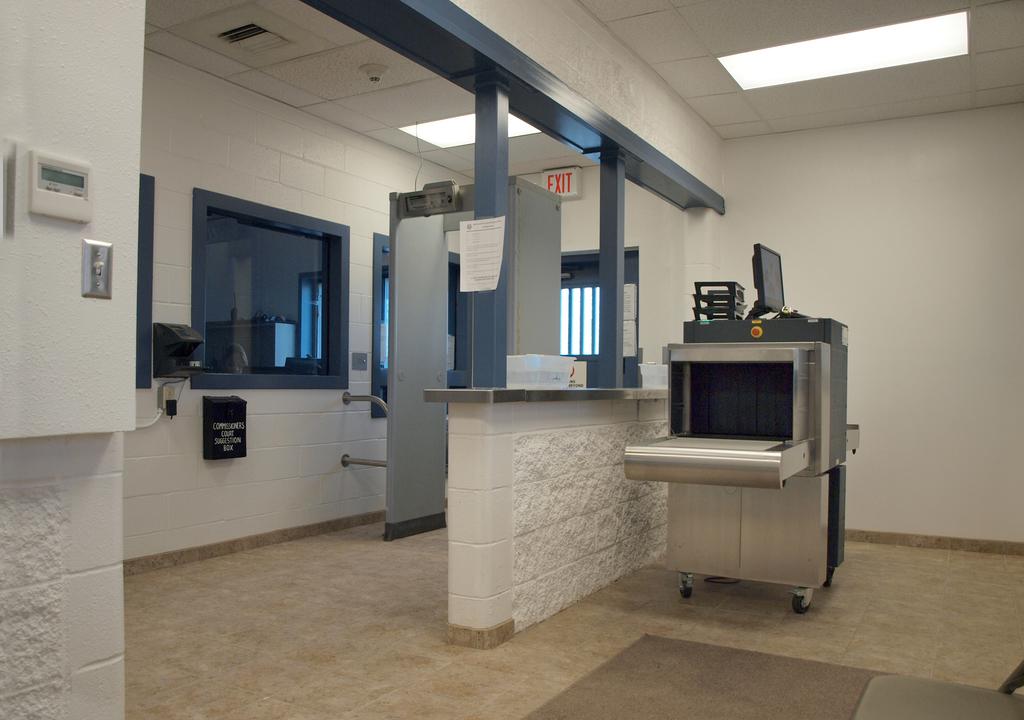Where does the door lead?
Offer a terse response. Exit. What does the box under the window say?
Make the answer very short. Unanswerable. 